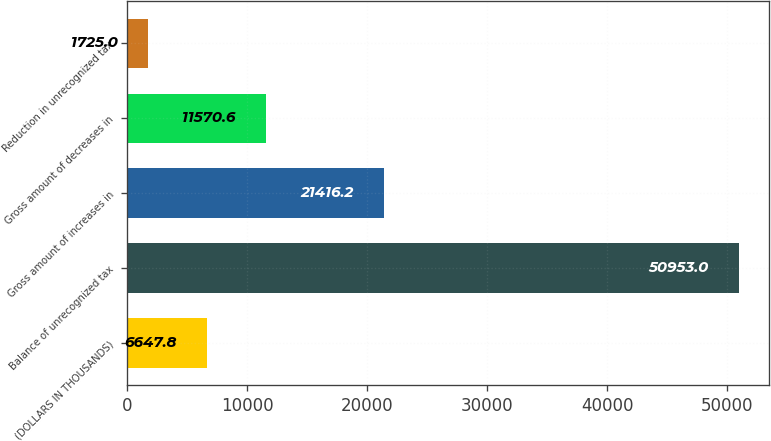<chart> <loc_0><loc_0><loc_500><loc_500><bar_chart><fcel>(DOLLARS IN THOUSANDS)<fcel>Balance of unrecognized tax<fcel>Gross amount of increases in<fcel>Gross amount of decreases in<fcel>Reduction in unrecognized tax<nl><fcel>6647.8<fcel>50953<fcel>21416.2<fcel>11570.6<fcel>1725<nl></chart> 